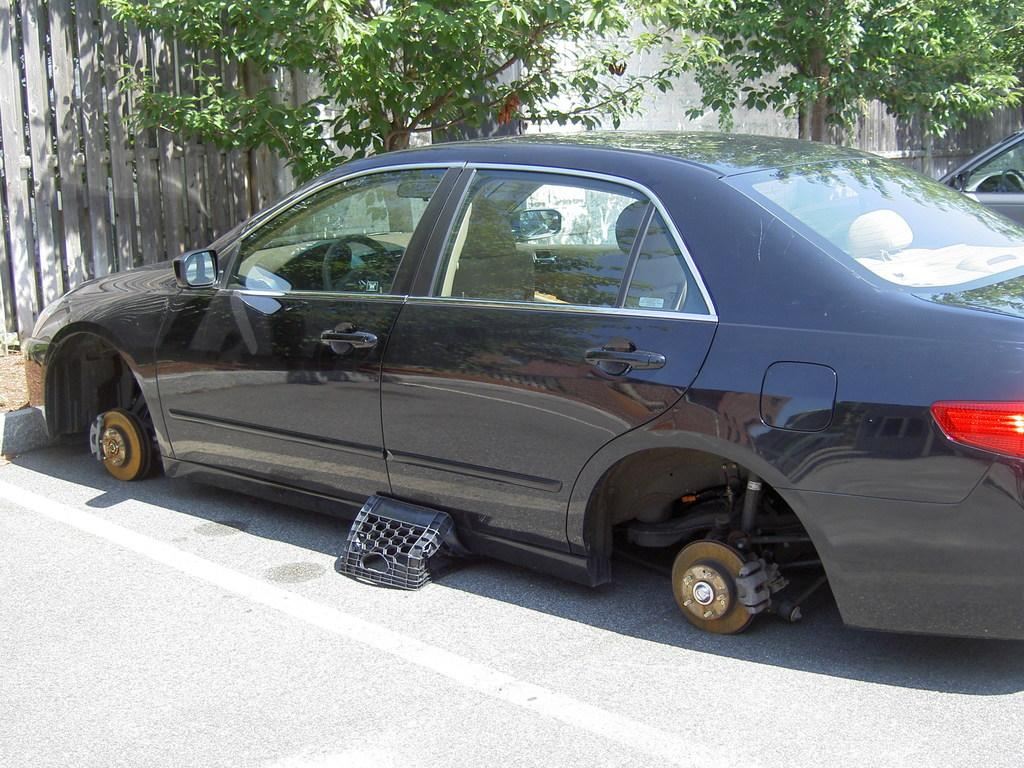What is the condition of the car in the image? The car in the image does not have tires. What other object can be seen in the image? There is a basket in the image. Are there any other vehicles visible in the image? Yes, there is another car visible in the image. What can be seen on the left side of the image? There are trees on the left side of the image. What type of structure is present in the image? There is a wall in the image. Reasoning: Let' Let's think step by step in order to produce the conversation. We start by identifying the main subject of the image, which is the car without tires. Then, we mention other objects and structures present in the image, such as the basket, the other car, the trees, and the wall. Each question is designed to elicit a specific detail about the image that is known from the provided facts. Absurd Question/Answer: What advertisement can be seen on the wall in the image? There is no advertisement visible on the wall in the image. How many family members are present in the image? There is no family present in the image; it only features a car without tires, a basket, another car, trees, and a wall. 